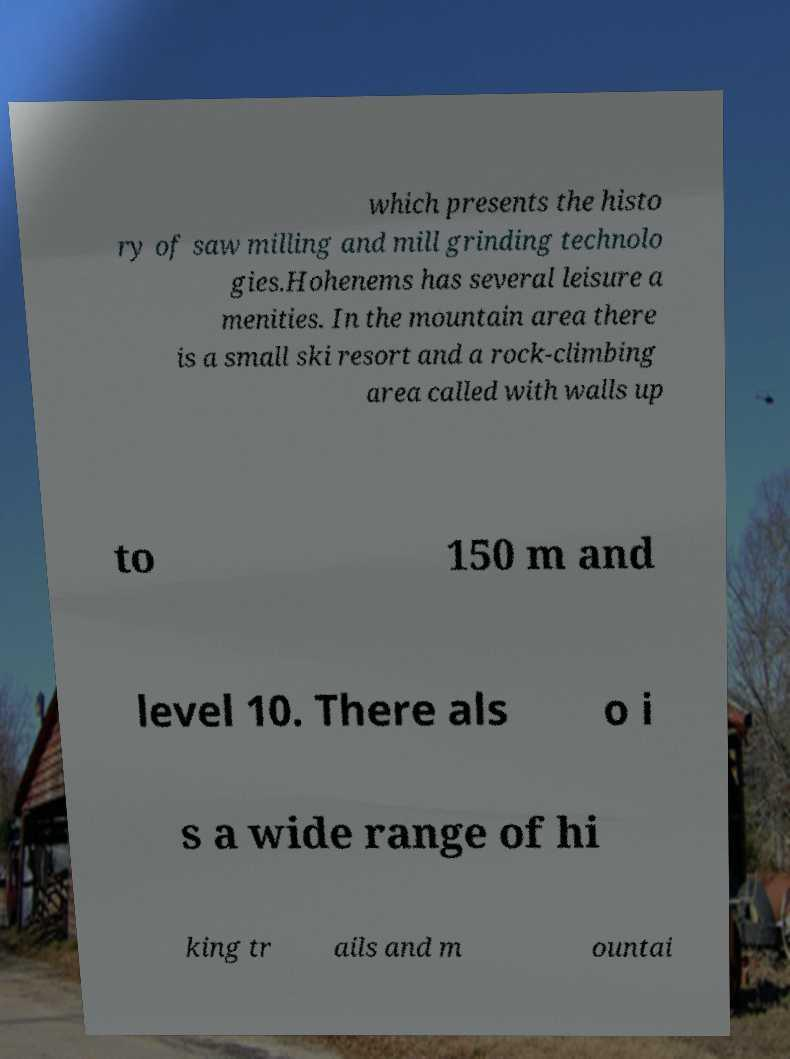I need the written content from this picture converted into text. Can you do that? which presents the histo ry of saw milling and mill grinding technolo gies.Hohenems has several leisure a menities. In the mountain area there is a small ski resort and a rock-climbing area called with walls up to 150 m and level 10. There als o i s a wide range of hi king tr ails and m ountai 